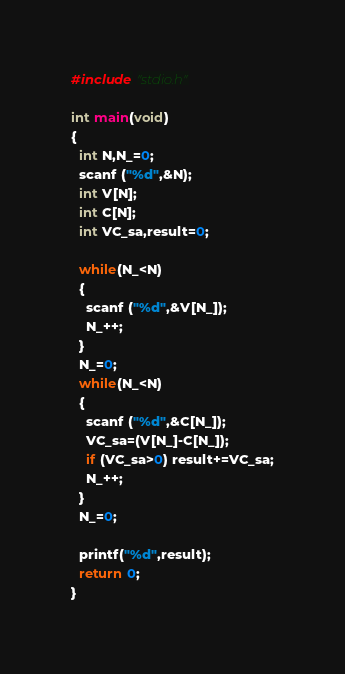Convert code to text. <code><loc_0><loc_0><loc_500><loc_500><_C_>#include "stdio.h"

int main(void)
{
  int N,N_=0;
  scanf ("%d",&N);
  int V[N];
  int C[N];
  int VC_sa,result=0;
  
  while(N_<N)
  {
    scanf ("%d",&V[N_]);
    N_++;
  }
  N_=0;
  while(N_<N)
  {
    scanf ("%d",&C[N_]);
    VC_sa=(V[N_]-C[N_]);
    if (VC_sa>0) result+=VC_sa;
    N_++;
  }
  N_=0;
  
  printf("%d",result);
  return 0;
}</code> 